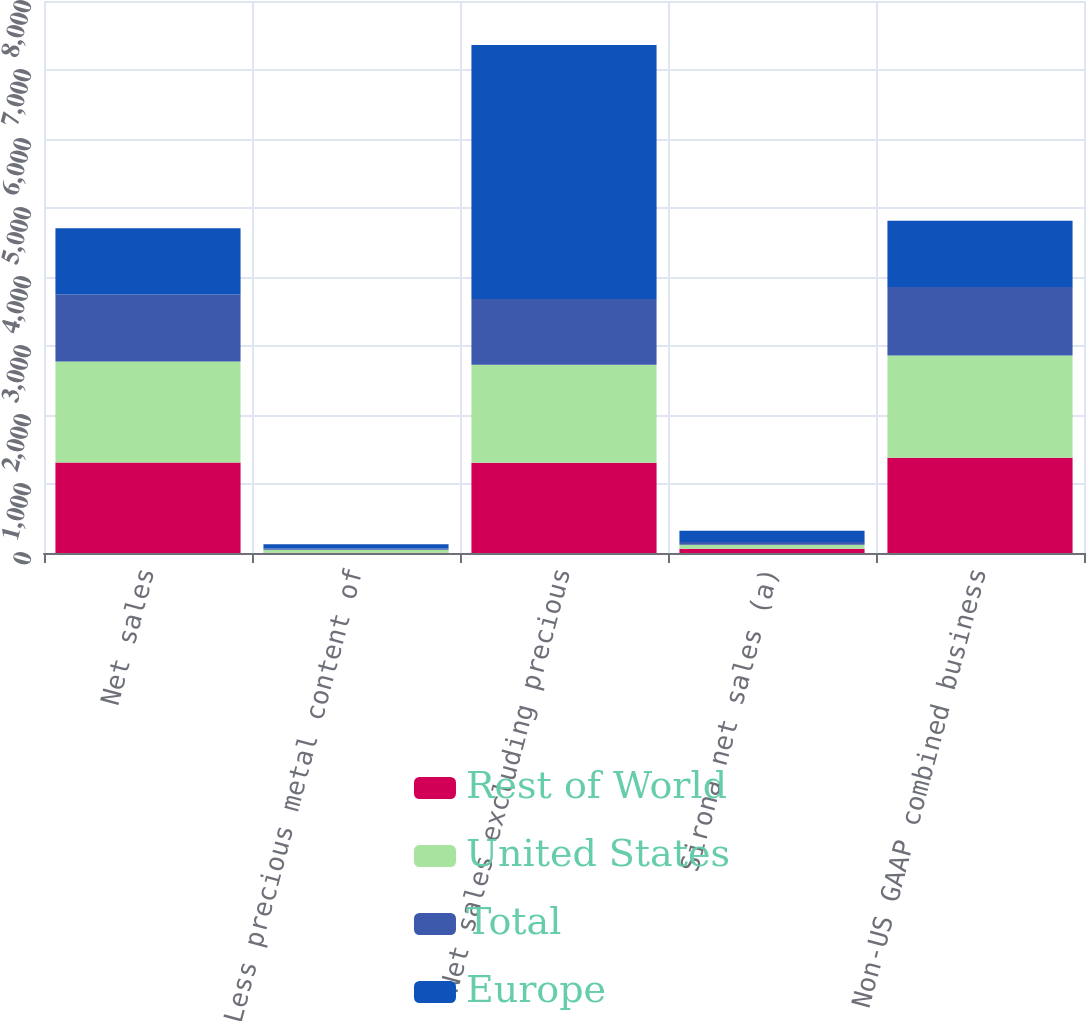Convert chart. <chart><loc_0><loc_0><loc_500><loc_500><stacked_bar_chart><ecel><fcel>Net sales<fcel>Less precious metal content of<fcel>Net sales excluding precious<fcel>Sirona net sales (a)<fcel>Non-US GAAP combined business<nl><fcel>Rest of World<fcel>1311.6<fcel>5.2<fcel>1306.4<fcel>60.5<fcel>1378.7<nl><fcel>United States<fcel>1463.2<fcel>41.5<fcel>1421.7<fcel>59.4<fcel>1482.3<nl><fcel>Total<fcel>970.5<fcel>17.6<fcel>952.9<fcel>40.8<fcel>993.7<nl><fcel>Europe<fcel>961.7<fcel>64.3<fcel>3681<fcel>160.7<fcel>961.7<nl></chart> 